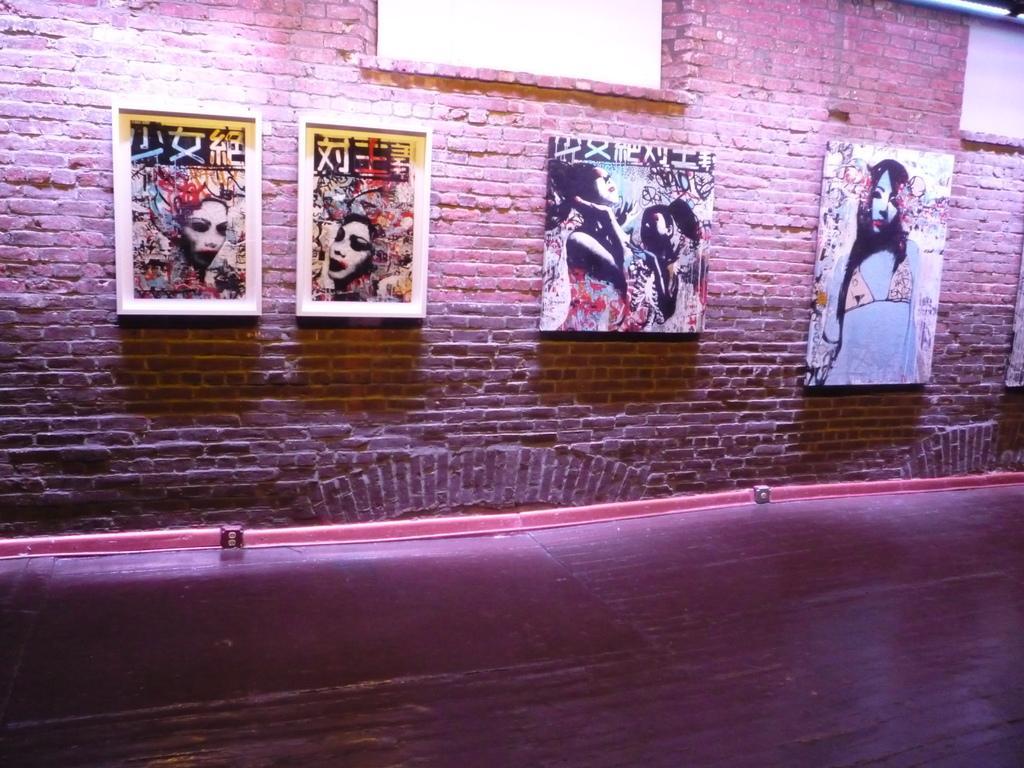Describe this image in one or two sentences. In this picture we can see a wall with the photo frames. 